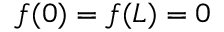<formula> <loc_0><loc_0><loc_500><loc_500>f ( 0 ) = f ( L ) = 0</formula> 